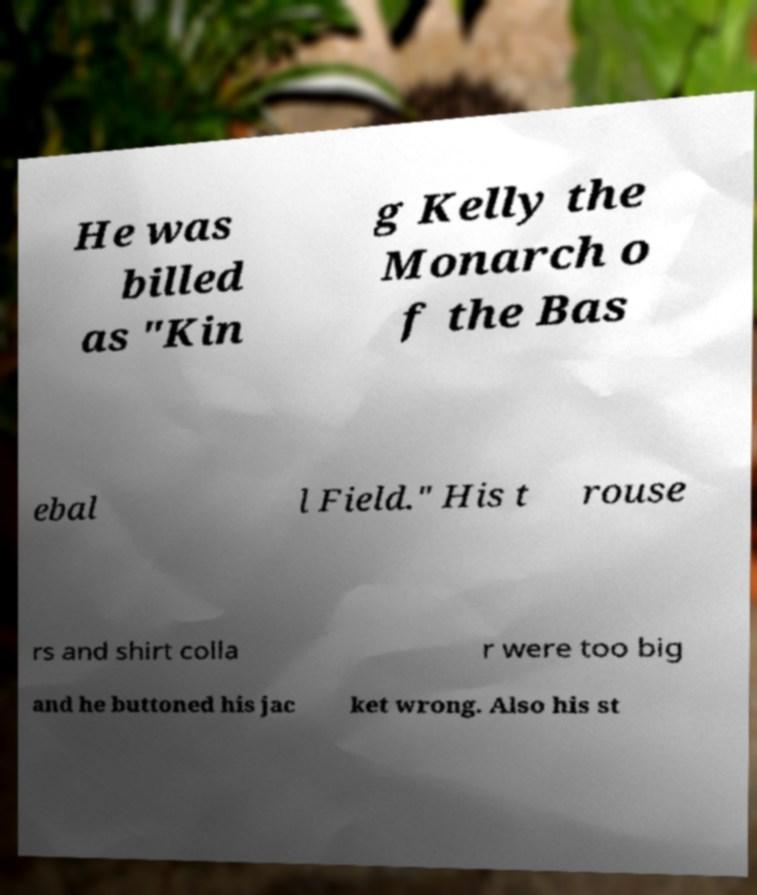Could you extract and type out the text from this image? He was billed as "Kin g Kelly the Monarch o f the Bas ebal l Field." His t rouse rs and shirt colla r were too big and he buttoned his jac ket wrong. Also his st 